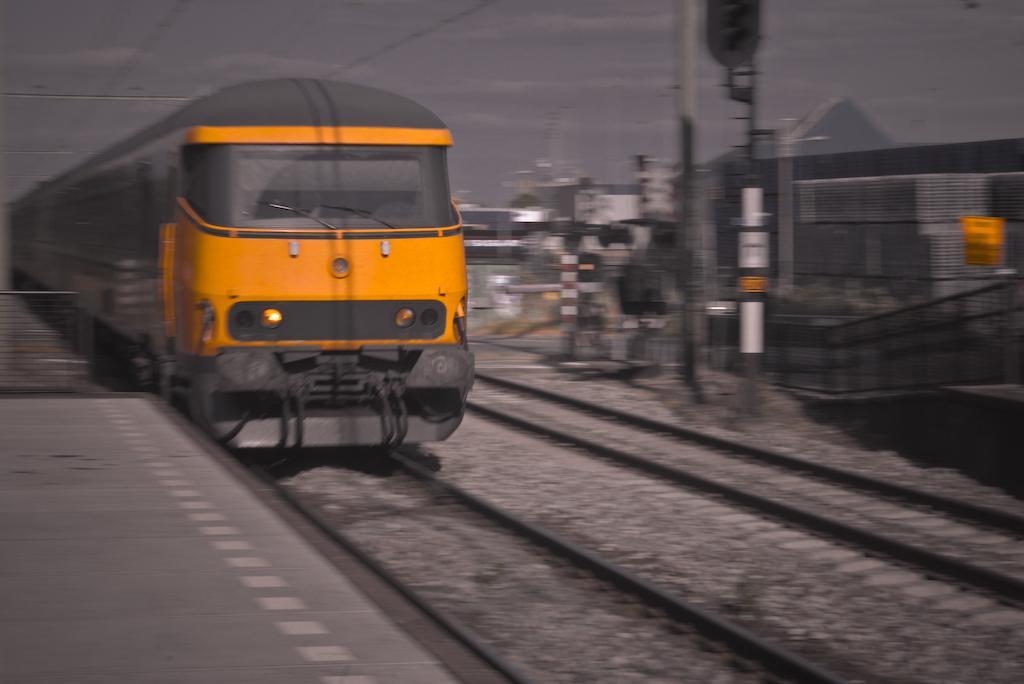Can you describe this image briefly? In the center of the image we can see a train on the track. In the background there are poles, fence and sky. There are wires. 